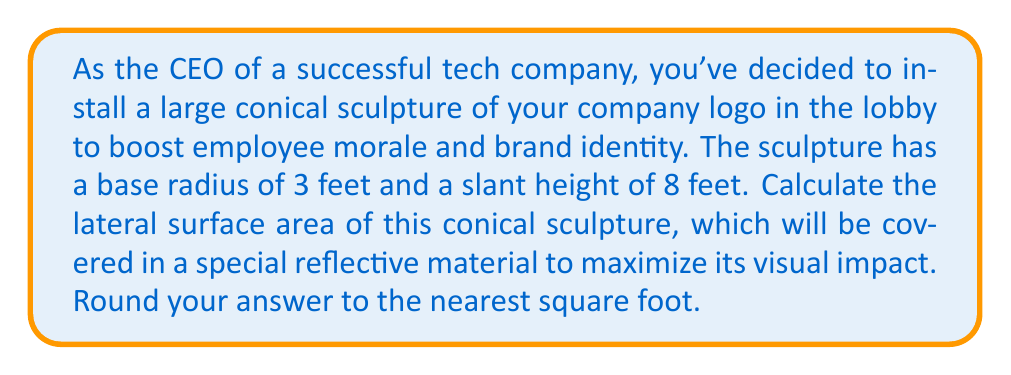Can you answer this question? To solve this problem, we'll follow these steps:

1) The formula for the lateral surface area of a cone is:

   $$A = \pi r s$$

   where $A$ is the lateral surface area, $r$ is the radius of the base, and $s$ is the slant height.

2) We're given:
   - Base radius $(r) = 3$ feet
   - Slant height $(s) = 8$ feet

3) Let's substitute these values into our formula:

   $$A = \pi \cdot 3 \cdot 8$$

4) Simplify:
   $$A = 24\pi$$

5) Calculate:
   $$A \approx 75.3982 \text{ square feet}$$

6) Rounding to the nearest square foot:
   $$A \approx 75 \text{ square feet}$$

This calculation gives us the area of the reflective material needed to cover the lateral surface of the conical sculpture, excluding the base.

[asy]
import geometry;

size(200);

pair O=(0,0);
pair A=(3,0);
pair B=(0,8);

draw(O--A--B--O);
draw(arc(O,3,0,360),dashed);

label("3'",A/2,S);
label("8'",B/2,NW);
label("r",(-1.5,0),S);

dot("O",O,SW);
[/asy]
Answer: 75 square feet 